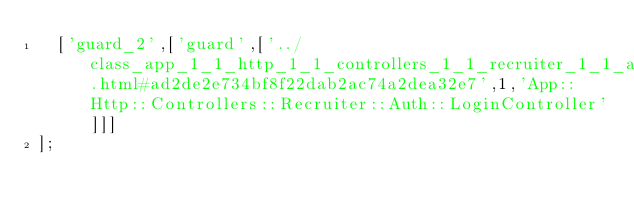Convert code to text. <code><loc_0><loc_0><loc_500><loc_500><_JavaScript_>  ['guard_2',['guard',['../class_app_1_1_http_1_1_controllers_1_1_recruiter_1_1_auth_1_1_login_controller.html#ad2de2e734bf8f22dab2ac74a2dea32e7',1,'App::Http::Controllers::Recruiter::Auth::LoginController']]]
];
</code> 